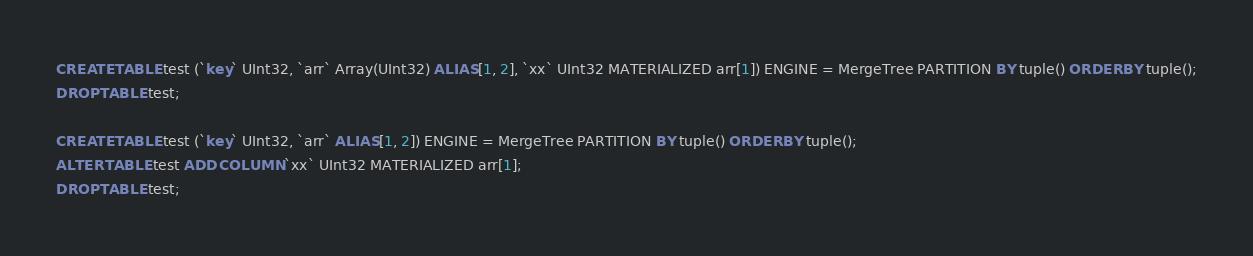Convert code to text. <code><loc_0><loc_0><loc_500><loc_500><_SQL_>CREATE TABLE test (`key` UInt32, `arr` Array(UInt32) ALIAS [1, 2], `xx` UInt32 MATERIALIZED arr[1]) ENGINE = MergeTree PARTITION BY tuple() ORDER BY tuple();
DROP TABLE test;

CREATE TABLE test (`key` UInt32, `arr` ALIAS [1, 2]) ENGINE = MergeTree PARTITION BY tuple() ORDER BY tuple();
ALTER TABLE test ADD COLUMN `xx` UInt32 MATERIALIZED arr[1];
DROP TABLE test;
</code> 